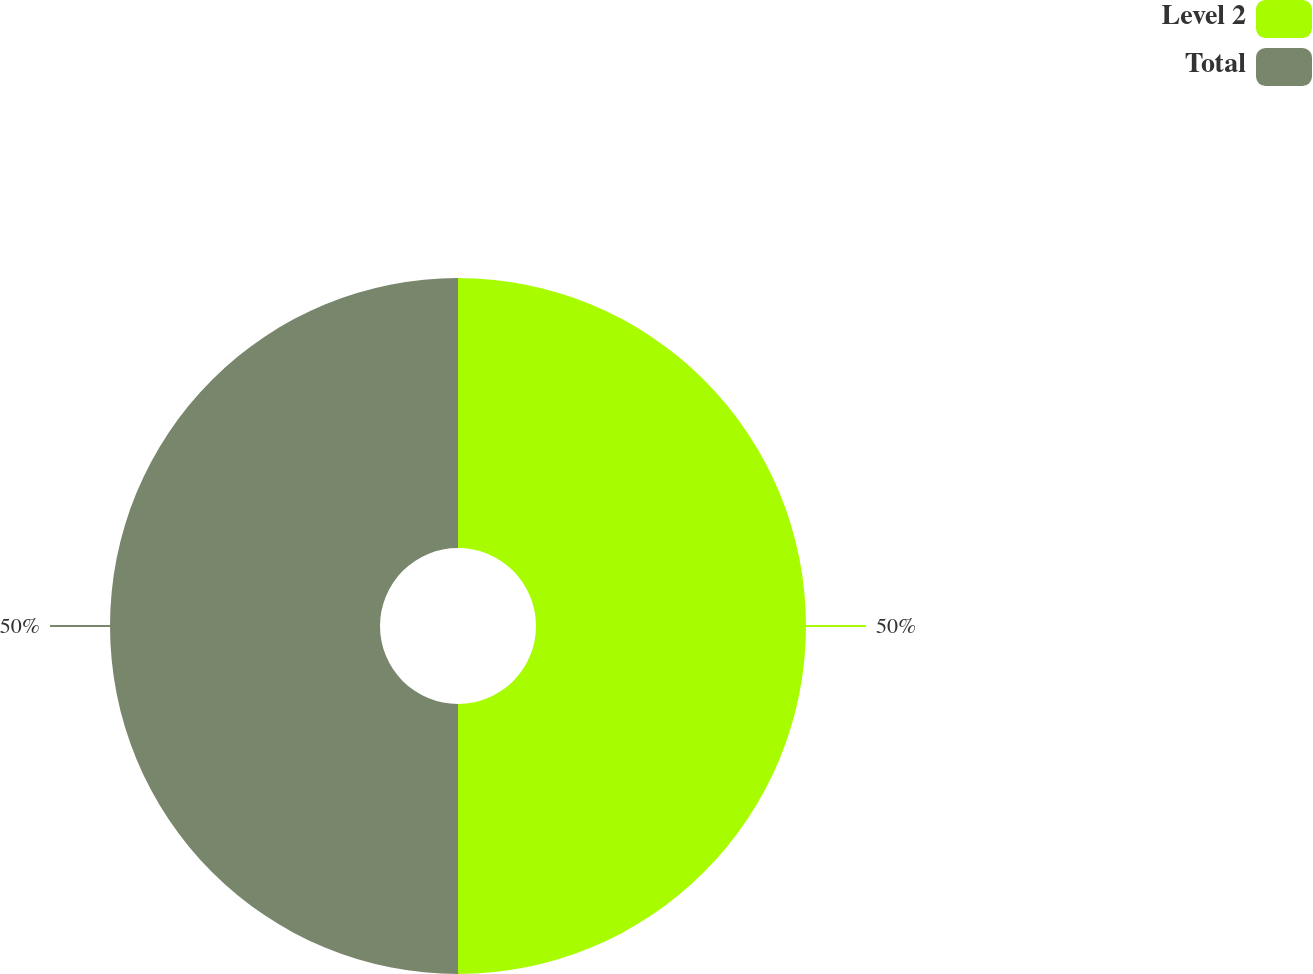Convert chart to OTSL. <chart><loc_0><loc_0><loc_500><loc_500><pie_chart><fcel>Level 2<fcel>Total<nl><fcel>50.0%<fcel>50.0%<nl></chart> 